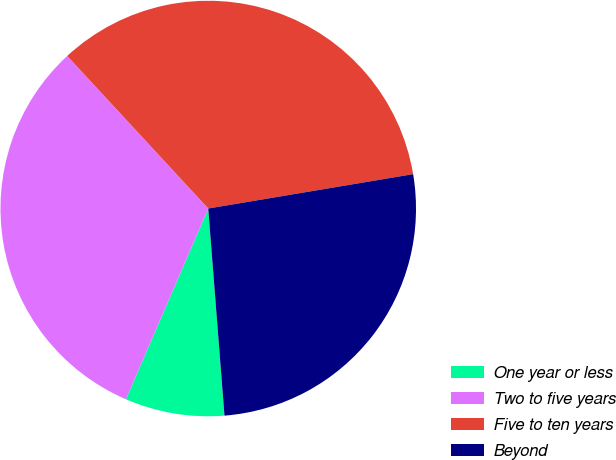Convert chart to OTSL. <chart><loc_0><loc_0><loc_500><loc_500><pie_chart><fcel>One year or less<fcel>Two to five years<fcel>Five to ten years<fcel>Beyond<nl><fcel>7.73%<fcel>31.64%<fcel>34.23%<fcel>26.4%<nl></chart> 